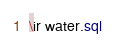<code> <loc_0><loc_0><loc_500><loc_500><_SQL_>\ir water.sql

</code> 